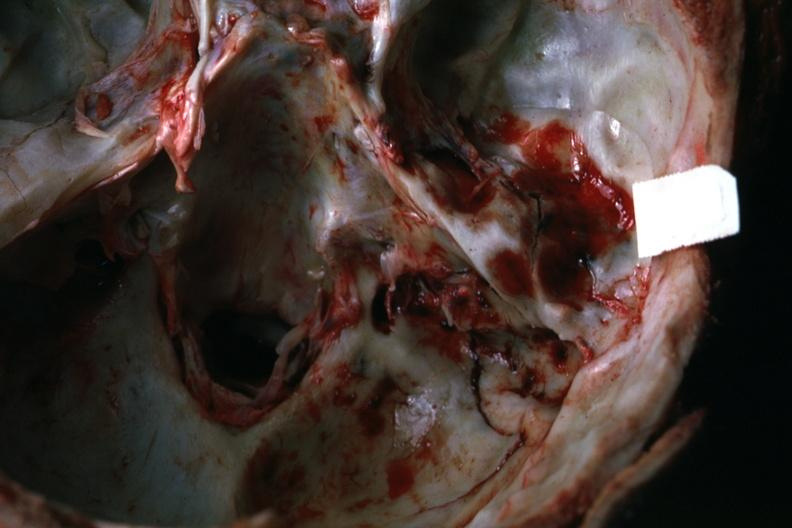s basilar skull fracture present?
Answer the question using a single word or phrase. Yes 